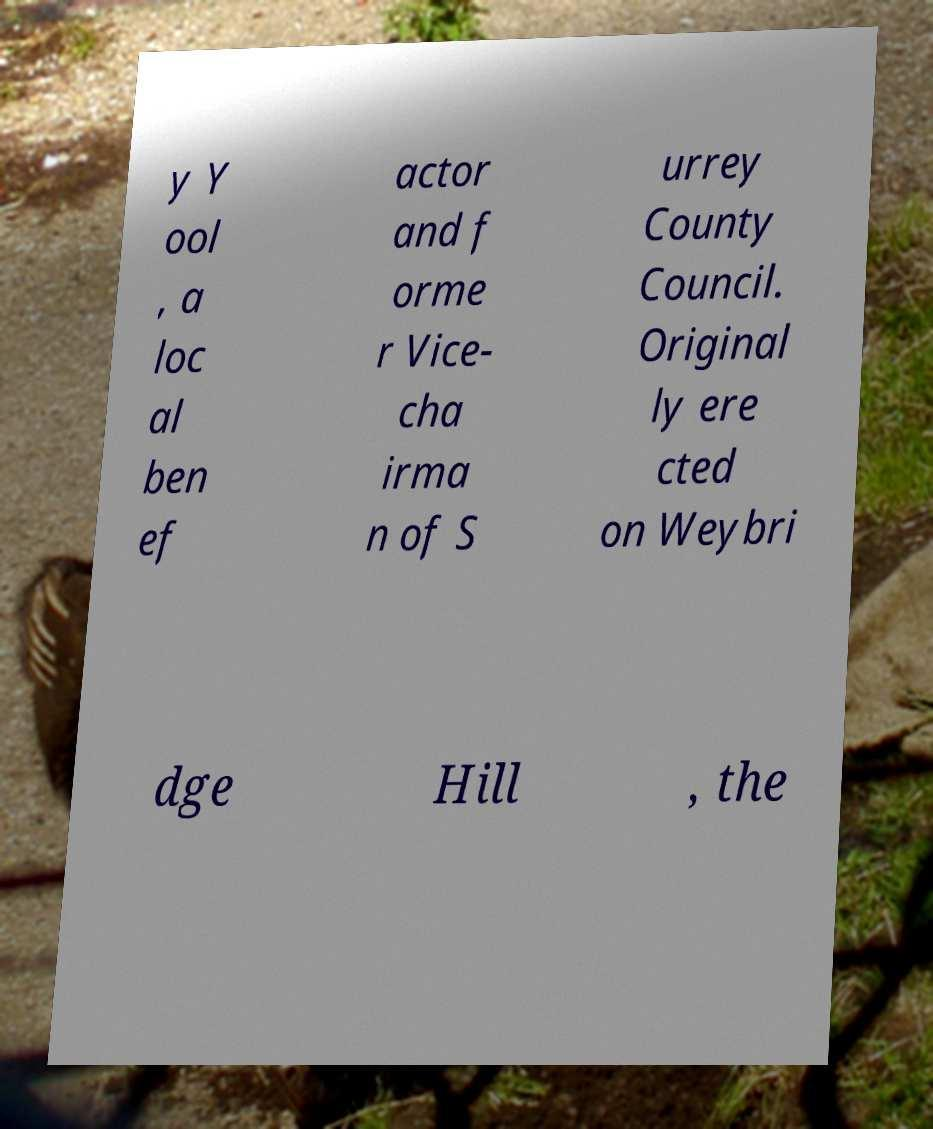Can you read and provide the text displayed in the image?This photo seems to have some interesting text. Can you extract and type it out for me? y Y ool , a loc al ben ef actor and f orme r Vice- cha irma n of S urrey County Council. Original ly ere cted on Weybri dge Hill , the 